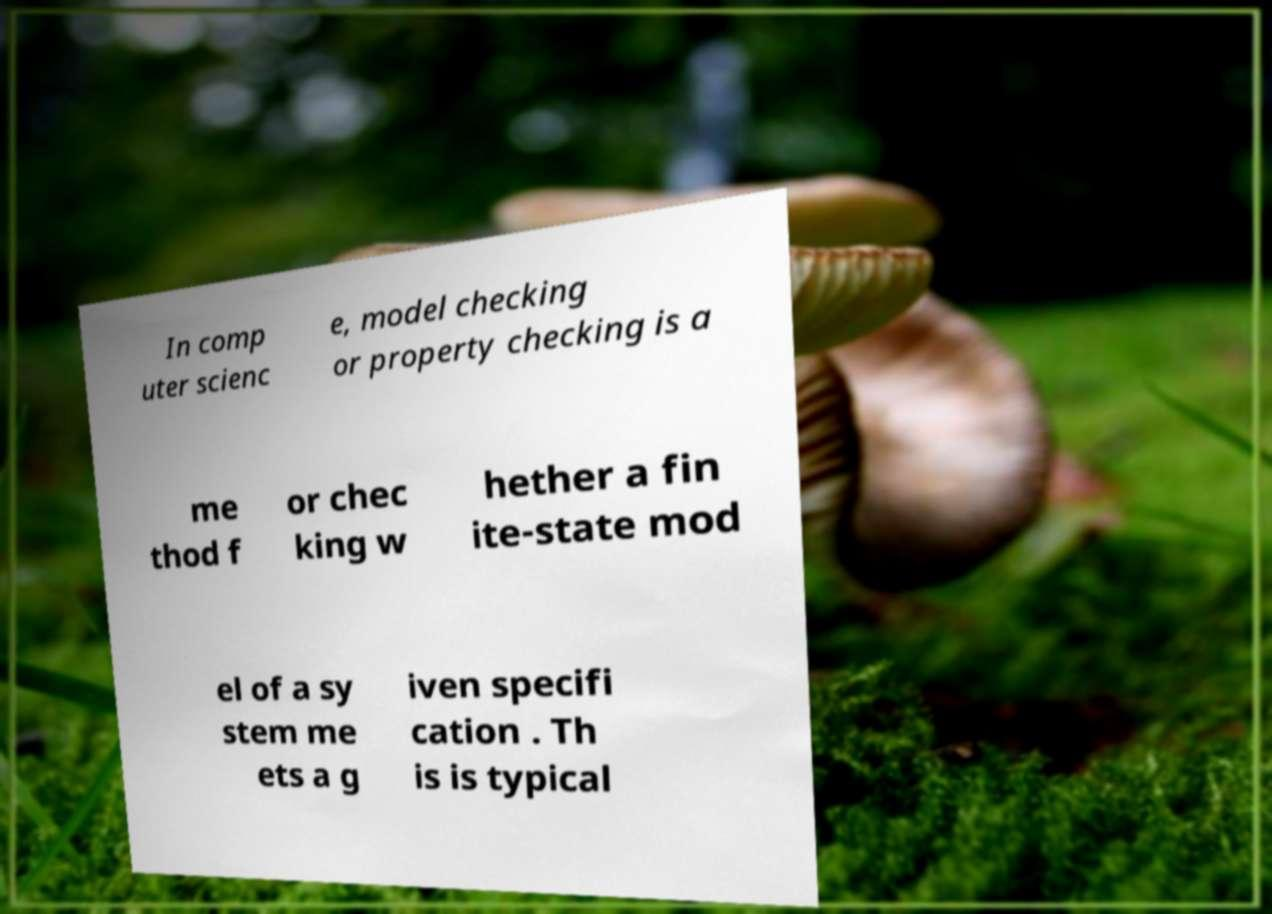Could you extract and type out the text from this image? In comp uter scienc e, model checking or property checking is a me thod f or chec king w hether a fin ite-state mod el of a sy stem me ets a g iven specifi cation . Th is is typical 